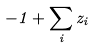Convert formula to latex. <formula><loc_0><loc_0><loc_500><loc_500>- 1 + \sum _ { i } z _ { i }</formula> 